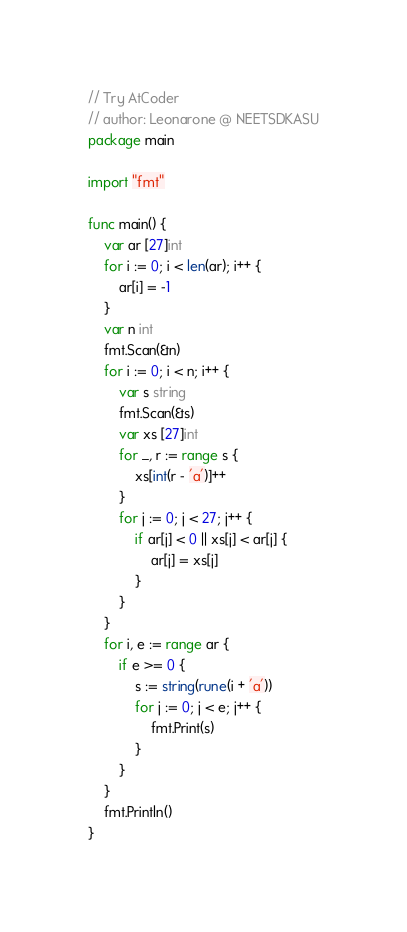<code> <loc_0><loc_0><loc_500><loc_500><_Go_>// Try AtCoder
// author: Leonarone @ NEETSDKASU
package main

import "fmt"

func main() {
    var ar [27]int
    for i := 0; i < len(ar); i++ {
        ar[i] = -1
    }
    var n int
    fmt.Scan(&n)
    for i := 0; i < n; i++ {
        var s string
        fmt.Scan(&s)
        var xs [27]int
        for _, r := range s {
            xs[int(r - 'a')]++
        }
        for j := 0; j < 27; j++ {
            if ar[j] < 0 || xs[j] < ar[j] {
                ar[j] = xs[j]
            }
        }
    }
    for i, e := range ar {
        if e >= 0 {
            s := string(rune(i + 'a'))
            for j := 0; j < e; j++ {
                fmt.Print(s)
            }
        }
    }
    fmt.Println()
}</code> 